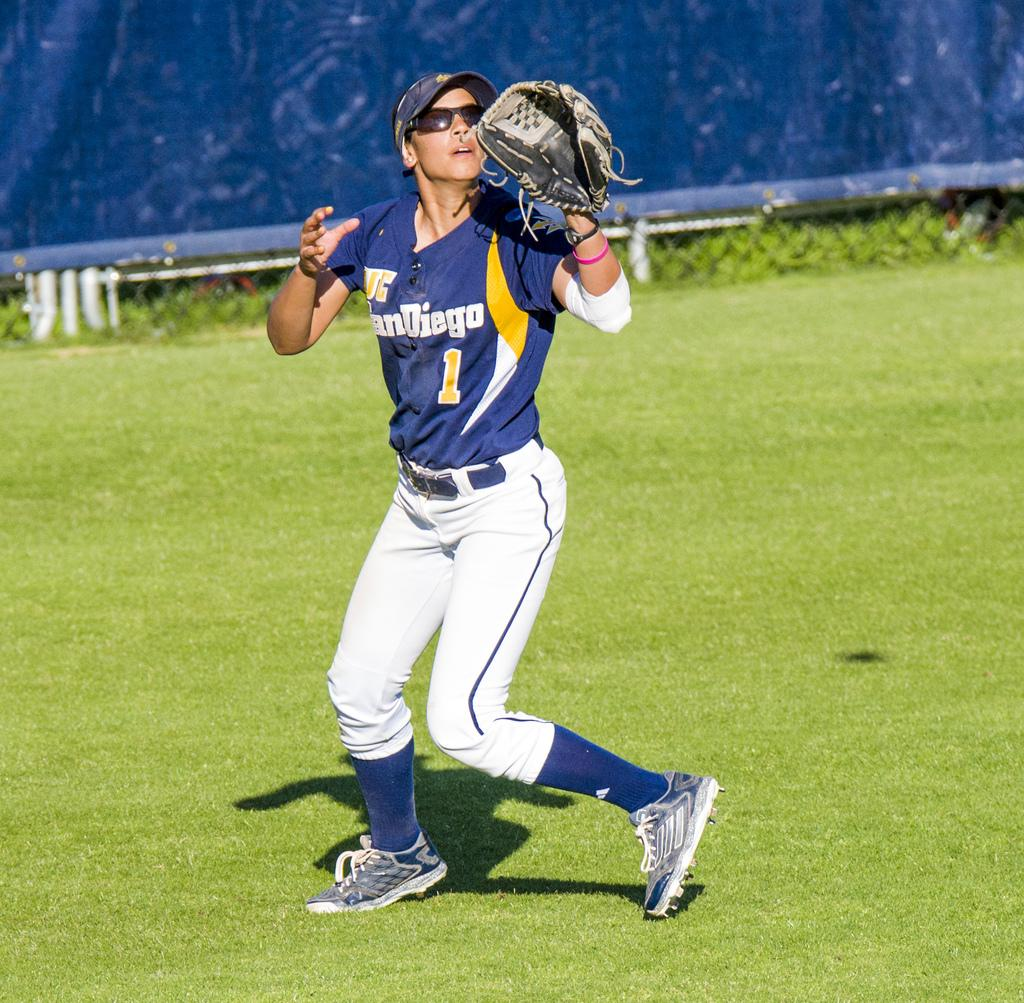<image>
Give a short and clear explanation of the subsequent image. The number 1 player from San Diego attempts to catch a ball while looking into the sun. 